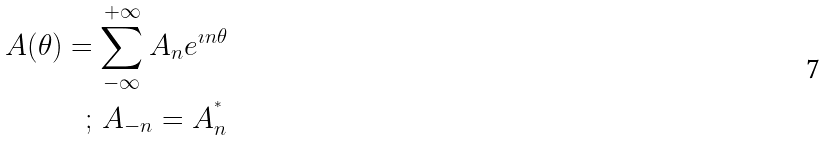<formula> <loc_0><loc_0><loc_500><loc_500>A ( \theta ) = \sum _ { - \infty } ^ { + \infty } A _ { n } e ^ { \imath n \theta } \\ ; \, A _ { - n } = A _ { n } ^ { ^ { * } }</formula> 